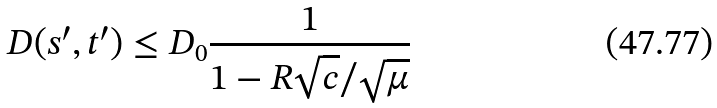<formula> <loc_0><loc_0><loc_500><loc_500>D ( s ^ { \prime } , t ^ { \prime } ) \leq D _ { 0 } \frac { 1 } { 1 - R \sqrt { c } / { \sqrt { \mu } } }</formula> 